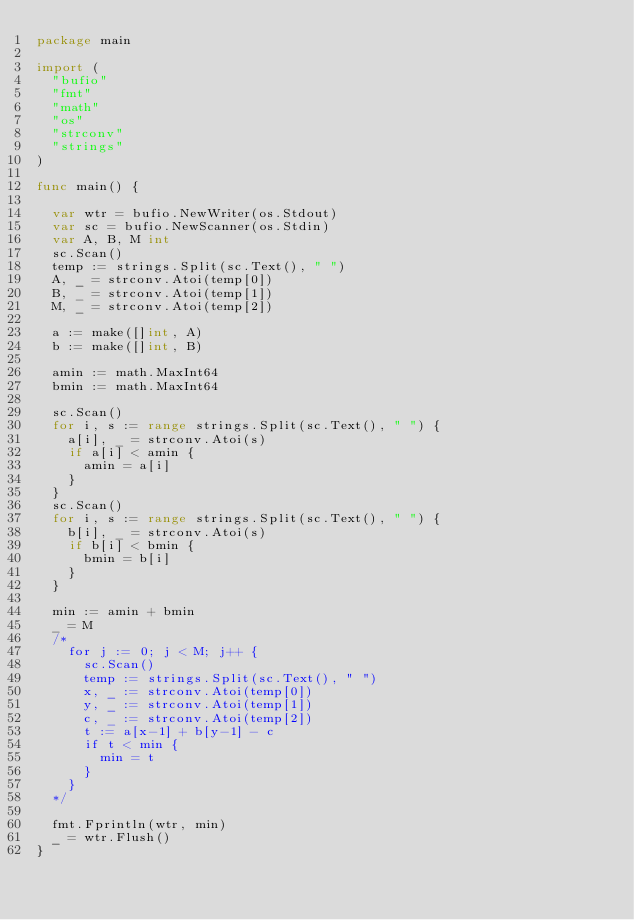Convert code to text. <code><loc_0><loc_0><loc_500><loc_500><_Go_>package main

import (
	"bufio"
	"fmt"
	"math"
	"os"
	"strconv"
	"strings"
)

func main() {

	var wtr = bufio.NewWriter(os.Stdout)
	var sc = bufio.NewScanner(os.Stdin)
	var A, B, M int
	sc.Scan()
	temp := strings.Split(sc.Text(), " ")
	A, _ = strconv.Atoi(temp[0])
	B, _ = strconv.Atoi(temp[1])
	M, _ = strconv.Atoi(temp[2])

	a := make([]int, A)
	b := make([]int, B)

	amin := math.MaxInt64
	bmin := math.MaxInt64

	sc.Scan()
	for i, s := range strings.Split(sc.Text(), " ") {
		a[i], _ = strconv.Atoi(s)
		if a[i] < amin {
			amin = a[i]
		}
	}
	sc.Scan()
	for i, s := range strings.Split(sc.Text(), " ") {
		b[i], _ = strconv.Atoi(s)
		if b[i] < bmin {
			bmin = b[i]
		}
	}

	min := amin + bmin
	_ = M
	/*
		for j := 0; j < M; j++ {
			sc.Scan()
			temp := strings.Split(sc.Text(), " ")
			x, _ := strconv.Atoi(temp[0])
			y, _ := strconv.Atoi(temp[1])
			c, _ := strconv.Atoi(temp[2])
			t := a[x-1] + b[y-1] - c
			if t < min {
				min = t
			}
		}
	*/

	fmt.Fprintln(wtr, min)
	_ = wtr.Flush()
}
</code> 